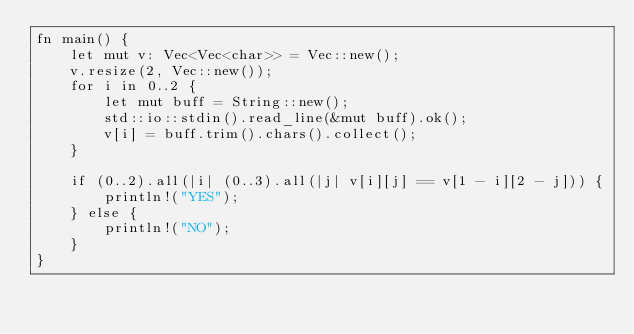<code> <loc_0><loc_0><loc_500><loc_500><_Rust_>fn main() {
    let mut v: Vec<Vec<char>> = Vec::new();
    v.resize(2, Vec::new());
    for i in 0..2 {
        let mut buff = String::new();
        std::io::stdin().read_line(&mut buff).ok();
        v[i] = buff.trim().chars().collect();
    }

    if (0..2).all(|i| (0..3).all(|j| v[i][j] == v[1 - i][2 - j])) {
        println!("YES");
    } else {
        println!("NO");
    }
}</code> 